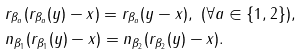<formula> <loc_0><loc_0><loc_500><loc_500>& r _ { \beta _ { a } } ( r _ { \beta _ { a } } ( y ) - x ) = r _ { \beta _ { a } } ( y - x ) , \ ( \forall a \in \{ 1 , 2 \} ) , \\ & n _ { \beta _ { 1 } } ( r _ { \beta _ { 1 } } ( y ) - x ) = n _ { \beta _ { 2 } } ( r _ { \beta _ { 2 } } ( y ) - x ) .</formula> 